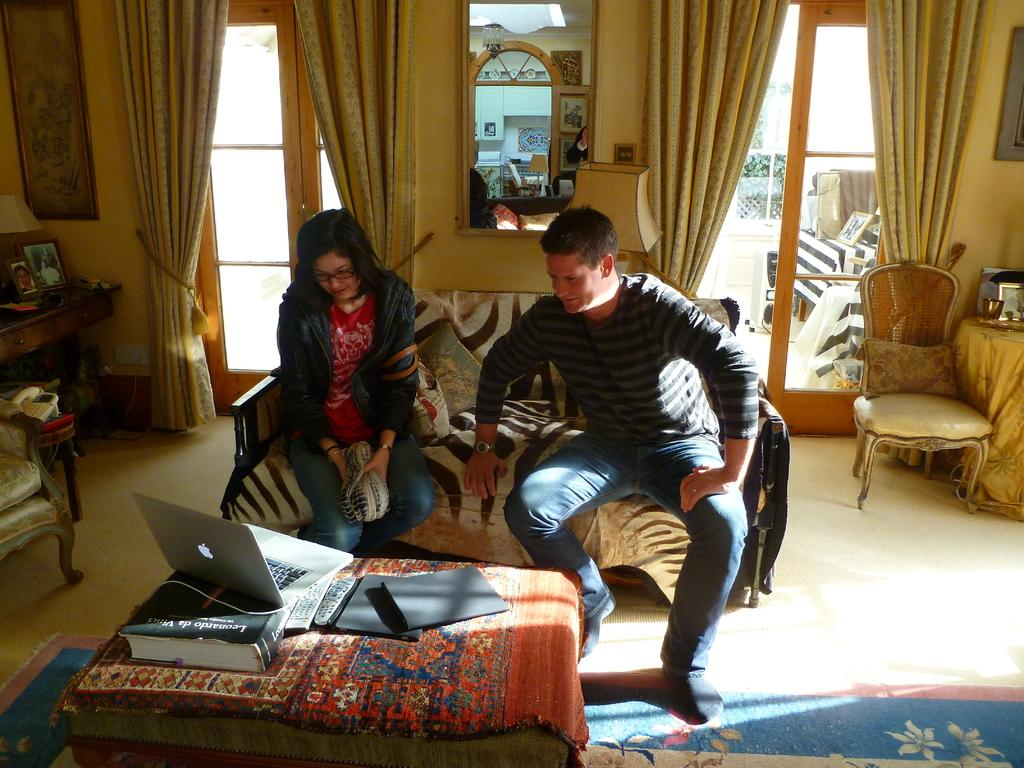Who are the people in the image? There is a man and a woman in the image. What are they doing in the image? They are sitting on a sofa and watching a laptop. What is on the table in front of them? The table has some books on it. What can be seen in the backdrop of the image? There is a curtain in the backdrop. What arithmetic problem are they solving together in the image? There is no arithmetic problem visible in the image; they are watching a laptop. How many vacations have they planned based on the number of books on the table? There is no indication of vacation planning in the image, and the number of books on the table cannot be determined. 